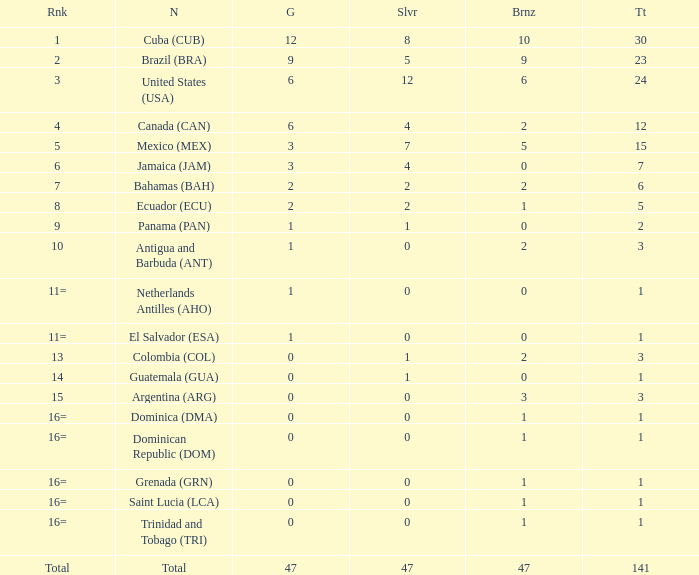What is the average silver with more than 0 gold, a Rank of 1, and a Total smaller than 30? None. 